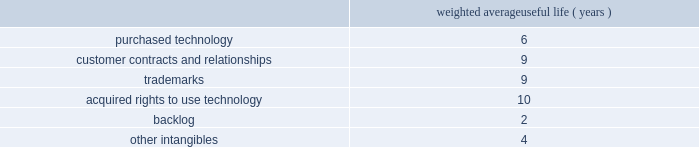Table of contents adobe inc .
Notes to consolidated financial statements ( continued ) goodwill , purchased intangibles and other long-lived assets goodwill is assigned to one or more reporting segments on the date of acquisition .
We review our goodwill for impairment annually during our second quarter of each fiscal year and between annual tests if an event occurs or circumstances change that would more likely than not reduce the fair value of any one of our reporting units below its respective carrying amount .
In performing our goodwill impairment test , we first perform a qualitative assessment , which requires that we consider events or circumstances including macroeconomic conditions , industry and market considerations , cost factors , overall financial performance , changes in management or key personnel , changes in strategy , changes in customers , changes in the composition or carrying amount of a reporting segment 2019s net assets and changes in our stock price .
If , after assessing the totality of events or circumstances , we determine that it is more likely than not that the fair values of our reporting segments are greater than the carrying amounts , then the quantitative goodwill impairment test is not performed .
If the qualitative assessment indicates that the quantitative analysis should be performed , we then evaluate goodwill for impairment by comparing the fair value of each of our reporting segments to its carrying value , including the associated goodwill .
To determine the fair values , we use the equal weighting of the market approach based on comparable publicly traded companies in similar lines of businesses and the income approach based on estimated discounted future cash flows .
Our cash flow assumptions consider historical and forecasted revenue , operating costs and other relevant factors .
We completed our annual goodwill impairment test in the second quarter of fiscal 2018 .
We determined , after performing a qualitative review of each reporting segment , that it is more likely than not that the fair value of each of our reporting segments substantially exceeds the respective carrying amounts .
Accordingly , there was no indication of impairment and the quantitative goodwill impairment test was not performed .
We did not identify any events or changes in circumstances since the performance of our annual goodwill impairment test that would require us to perform another goodwill impairment test during the fiscal year .
We amortize intangible assets with finite lives over their estimated useful lives and review them for impairment whenever an impairment indicator exists .
We continually monitor events and changes in circumstances that could indicate carrying amounts of our long-lived assets , including our intangible assets may not be recoverable .
When such events or changes in circumstances occur , we assess recoverability by determining whether the carrying value of such assets will be recovered through the undiscounted expected future cash flows .
If the future undiscounted cash flows are less than the carrying amount of these assets , we recognize an impairment loss based on any excess of the carrying amount over the fair value of the assets .
We did not recognize any intangible asset impairment charges in fiscal 2018 , 2017 or 2016 .
During fiscal 2018 , our intangible assets were amortized over their estimated useful lives ranging from 1 to 14 years .
Amortization is based on the pattern in which the economic benefits of the intangible asset will be consumed or on a straight-line basis when the consumption pattern is not apparent .
The weighted average useful lives of our intangible assets were as follows : weighted average useful life ( years ) .
Income taxes we use the asset and liability method of accounting for income taxes .
Under this method , income tax expense is recognized for the amount of taxes payable or refundable for the current year .
In addition , deferred tax assets and liabilities are recognized for expected future tax consequences of temporary differences between the financial reporting and tax bases of assets and liabilities , and for operating losses and tax credit carryforwards .
We record a valuation allowance to reduce deferred tax assets to an amount for which realization is more likely than not. .
For the weighted average useful lives of our intangible assets , what was the average weighted average useful life ( years ) for purchased technology and customer contracts and relationships? 
Computations: ((6 + 9) / 2)
Answer: 7.5. 